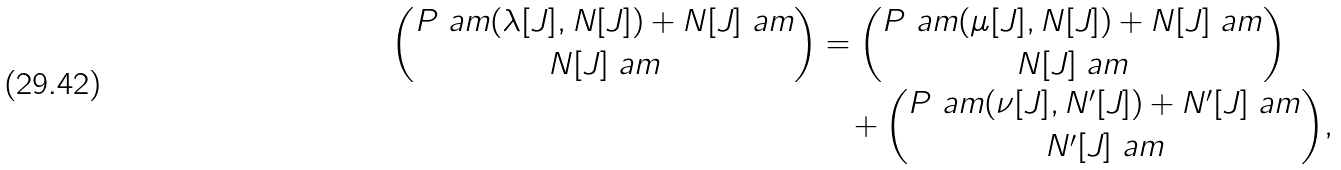Convert formula to latex. <formula><loc_0><loc_0><loc_500><loc_500>\binom { P \ a m ( \lambda [ J ] , N [ J ] ) + N [ J ] \ a m } { N [ J ] \ a m } & = \binom { P \ a m ( \mu [ J ] , N [ J ] ) + N [ J ] \ a m } { N [ J ] \ a m } \\ & \quad + \binom { P \ a m ( \nu [ J ] , N ^ { \prime } [ J ] ) + N ^ { \prime } [ J ] \ a m } { N ^ { \prime } [ J ] \ a m } ,</formula> 